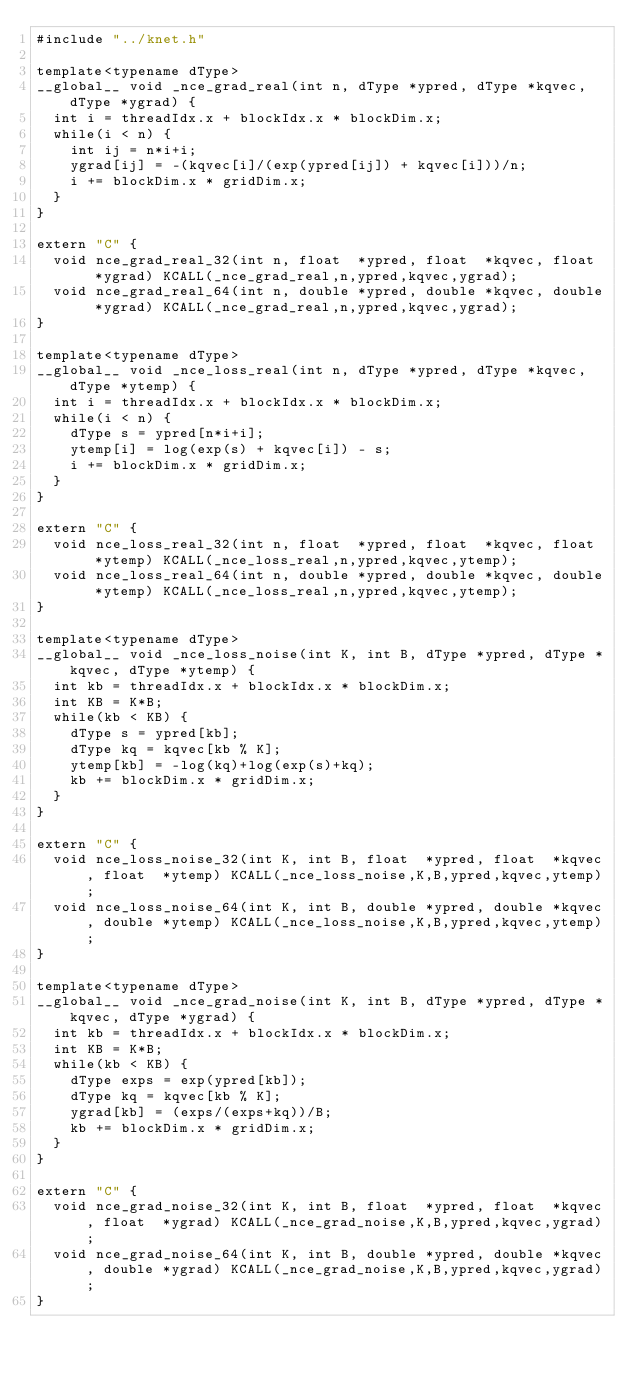Convert code to text. <code><loc_0><loc_0><loc_500><loc_500><_Cuda_>#include "../knet.h"

template<typename dType>
__global__ void _nce_grad_real(int n, dType *ypred, dType *kqvec, dType *ygrad) {
  int i = threadIdx.x + blockIdx.x * blockDim.x;
  while(i < n) {
    int ij = n*i+i;
    ygrad[ij] = -(kqvec[i]/(exp(ypred[ij]) + kqvec[i]))/n;
    i += blockDim.x * gridDim.x;
  }
}

extern "C" {
  void nce_grad_real_32(int n, float  *ypred, float  *kqvec, float  *ygrad) KCALL(_nce_grad_real,n,ypred,kqvec,ygrad);
  void nce_grad_real_64(int n, double *ypred, double *kqvec, double *ygrad) KCALL(_nce_grad_real,n,ypred,kqvec,ygrad);
}

template<typename dType>
__global__ void _nce_loss_real(int n, dType *ypred, dType *kqvec, dType *ytemp) {
  int i = threadIdx.x + blockIdx.x * blockDim.x;
  while(i < n) {
    dType s = ypred[n*i+i];
    ytemp[i] = log(exp(s) + kqvec[i]) - s;
    i += blockDim.x * gridDim.x;
  }
}

extern "C" {
  void nce_loss_real_32(int n, float  *ypred, float  *kqvec, float  *ytemp) KCALL(_nce_loss_real,n,ypred,kqvec,ytemp);
  void nce_loss_real_64(int n, double *ypred, double *kqvec, double *ytemp) KCALL(_nce_loss_real,n,ypred,kqvec,ytemp);
}

template<typename dType>
__global__ void _nce_loss_noise(int K, int B, dType *ypred, dType *kqvec, dType *ytemp) {
  int kb = threadIdx.x + blockIdx.x * blockDim.x;
  int KB = K*B;
  while(kb < KB) {
    dType s = ypred[kb];
    dType kq = kqvec[kb % K];
    ytemp[kb] = -log(kq)+log(exp(s)+kq);
    kb += blockDim.x * gridDim.x;
  }
}

extern "C" {
  void nce_loss_noise_32(int K, int B, float  *ypred, float  *kqvec, float  *ytemp) KCALL(_nce_loss_noise,K,B,ypred,kqvec,ytemp);
  void nce_loss_noise_64(int K, int B, double *ypred, double *kqvec, double *ytemp) KCALL(_nce_loss_noise,K,B,ypred,kqvec,ytemp);
}

template<typename dType>
__global__ void _nce_grad_noise(int K, int B, dType *ypred, dType *kqvec, dType *ygrad) {
  int kb = threadIdx.x + blockIdx.x * blockDim.x;
  int KB = K*B;
  while(kb < KB) {
    dType exps = exp(ypred[kb]);
    dType kq = kqvec[kb % K];
    ygrad[kb] = (exps/(exps+kq))/B;
    kb += blockDim.x * gridDim.x;
  }
}

extern "C" {
  void nce_grad_noise_32(int K, int B, float  *ypred, float  *kqvec, float  *ygrad) KCALL(_nce_grad_noise,K,B,ypred,kqvec,ygrad);
  void nce_grad_noise_64(int K, int B, double *ypred, double *kqvec, double *ygrad) KCALL(_nce_grad_noise,K,B,ypred,kqvec,ygrad);
}

</code> 